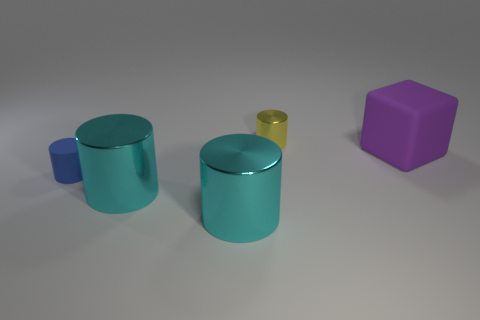What material is the thing that is behind the tiny matte thing and on the left side of the big purple rubber block?
Your answer should be very brief. Metal. The matte cylinder is what color?
Offer a terse response. Blue. How many small yellow objects have the same shape as the blue object?
Make the answer very short. 1. Does the small object behind the small blue matte thing have the same material as the big object that is behind the small matte cylinder?
Provide a short and direct response. No. What is the size of the matte thing left of the small cylinder behind the purple cube?
Your answer should be compact. Small. There is another blue thing that is the same shape as the small metallic object; what is its material?
Provide a short and direct response. Rubber. Do the metal object that is behind the purple block and the big thing to the right of the tiny yellow shiny cylinder have the same shape?
Offer a very short reply. No. Are there more tiny cylinders than objects?
Offer a terse response. No. The yellow thing is what size?
Offer a terse response. Small. What number of other objects are the same color as the tiny rubber cylinder?
Provide a succinct answer. 0. 